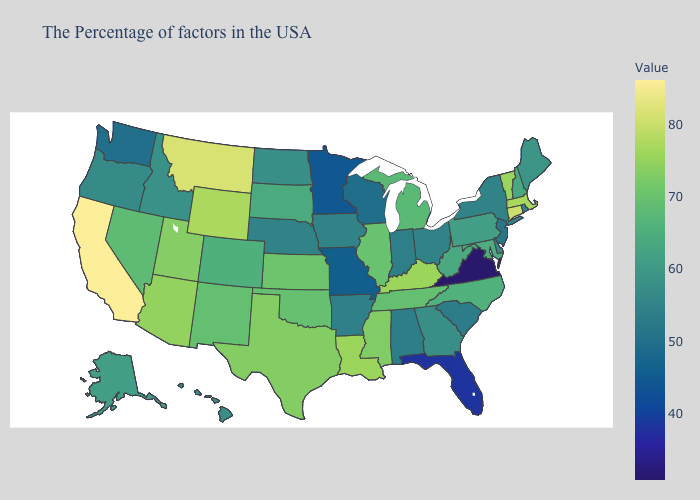Does Louisiana have the highest value in the South?
Short answer required. Yes. Does California have the highest value in the USA?
Be succinct. Yes. Does Michigan have a lower value than Alaska?
Give a very brief answer. No. Which states hav the highest value in the West?
Quick response, please. California. Does the map have missing data?
Give a very brief answer. No. Does Maine have the lowest value in the Northeast?
Be succinct. No. Among the states that border North Carolina , which have the highest value?
Short answer required. Tennessee. 